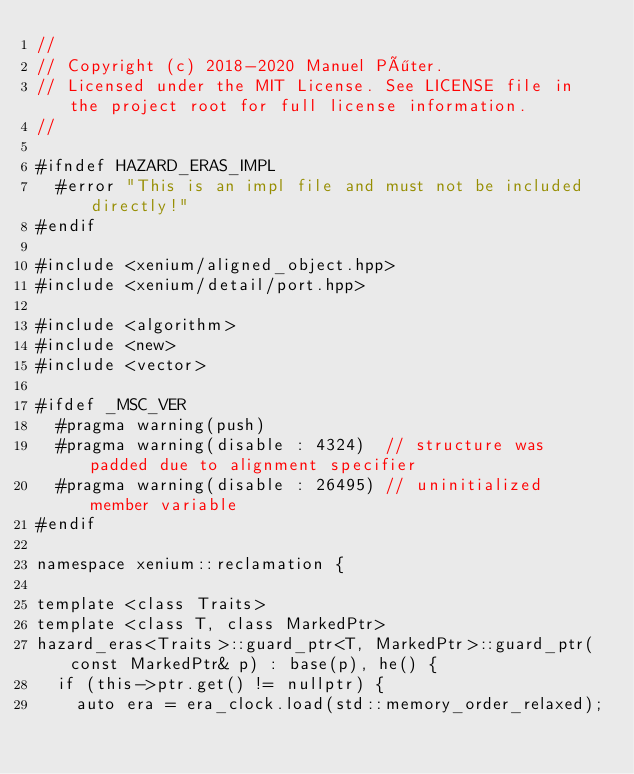<code> <loc_0><loc_0><loc_500><loc_500><_C++_>//
// Copyright (c) 2018-2020 Manuel Pöter.
// Licensed under the MIT License. See LICENSE file in the project root for full license information.
//

#ifndef HAZARD_ERAS_IMPL
  #error "This is an impl file and must not be included directly!"
#endif

#include <xenium/aligned_object.hpp>
#include <xenium/detail/port.hpp>

#include <algorithm>
#include <new>
#include <vector>

#ifdef _MSC_VER
  #pragma warning(push)
  #pragma warning(disable : 4324)  // structure was padded due to alignment specifier
  #pragma warning(disable : 26495) // uninitialized member variable
#endif

namespace xenium::reclamation {

template <class Traits>
template <class T, class MarkedPtr>
hazard_eras<Traits>::guard_ptr<T, MarkedPtr>::guard_ptr(const MarkedPtr& p) : base(p), he() {
  if (this->ptr.get() != nullptr) {
    auto era = era_clock.load(std::memory_order_relaxed);</code> 